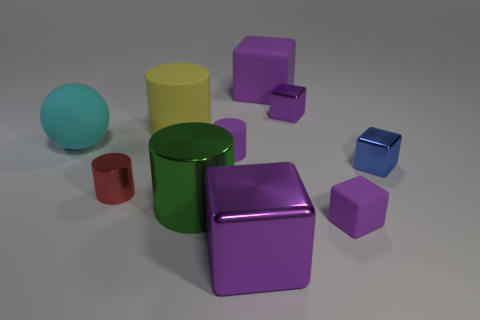There is a cylinder that is the same color as the large matte cube; what size is it?
Offer a very short reply. Small. The tiny object that is behind the tiny purple rubber thing that is behind the large metallic thing behind the big purple metal object is what shape?
Give a very brief answer. Cube. The big object that is both on the right side of the big green cylinder and in front of the tiny red shiny thing is made of what material?
Make the answer very short. Metal. What shape is the small shiny thing that is behind the tiny cylinder that is on the right side of the red cylinder?
Give a very brief answer. Cube. Are there any other things that are the same color as the large metallic cylinder?
Give a very brief answer. No. Do the red cylinder and the purple matte object that is in front of the tiny rubber cylinder have the same size?
Keep it short and to the point. Yes. How many tiny things are metallic blocks or matte blocks?
Make the answer very short. 3. Are there more big blue metal spheres than yellow cylinders?
Give a very brief answer. No. There is a tiny metallic cylinder that is in front of the big yellow rubber thing behind the cyan matte sphere; how many metallic objects are behind it?
Provide a succinct answer. 2. The big yellow matte object has what shape?
Keep it short and to the point. Cylinder. 